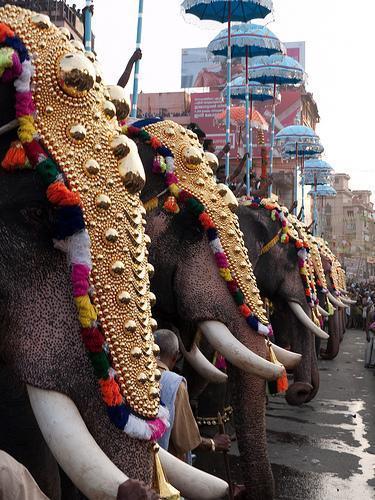How many men are near the elephants?
Give a very brief answer. 2. 